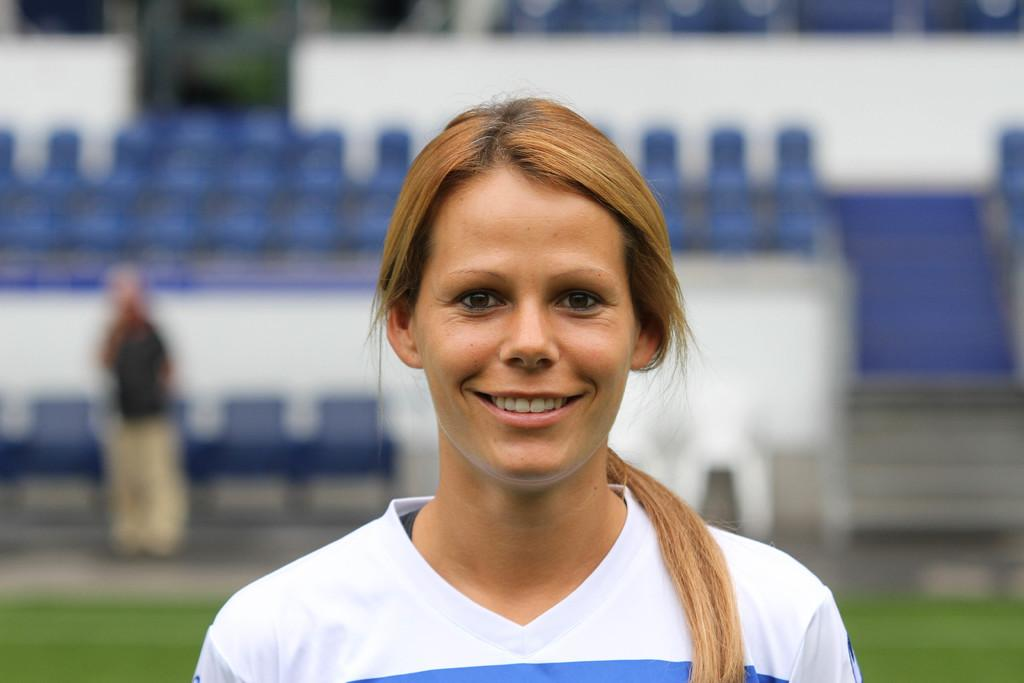Who is present in the image? There are women in the image. What are the women doing in the image? The women are smiling in the image. What furniture is visible in the image? There are chairs in the image. Can you describe the background of the image? There is a person standing in the background, and grass is visible on the ground. What type of food is being served at the harbor in the image? There is no harbor or food present in the image; it features women sitting on chairs and smiling. What scientific theory is being discussed by the women in the image? There is no indication in the image that the women are discussing any scientific theories. 